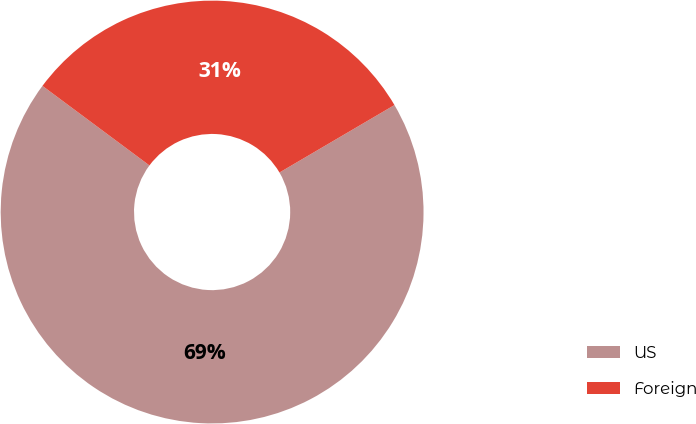Convert chart to OTSL. <chart><loc_0><loc_0><loc_500><loc_500><pie_chart><fcel>US<fcel>Foreign<nl><fcel>68.62%<fcel>31.38%<nl></chart> 